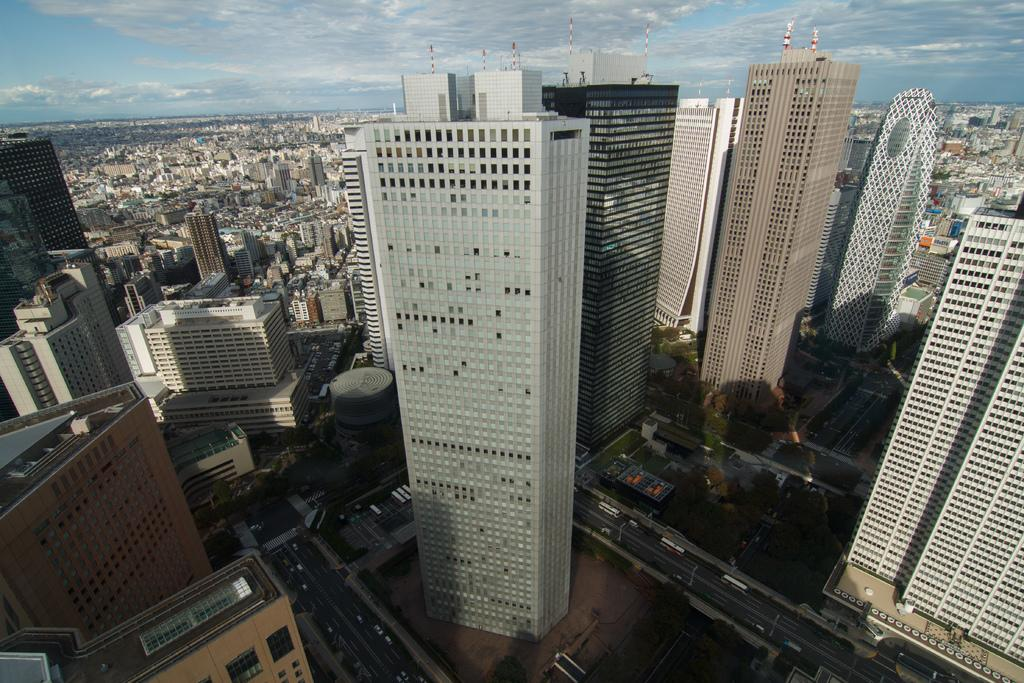What perspective is used to capture the image? The image is taken from a top view. What type of structures can be seen in the image? There are many buildings in the image. What other natural elements are visible in the image? Trees are visible in the image. What is happening on the road in the image? Vehicles are present on the road in the image. What part of the natural environment is visible in the image? The sky is visible in the image. What is the condition of the sky in the image? Clouds are present in the sky. What type of breakfast is being served in the image? There is no breakfast present in the image; it features a top view of buildings, trees, vehicles, and the sky. What type of business is being conducted in the image? There is no indication of any specific business being conducted in the image. 